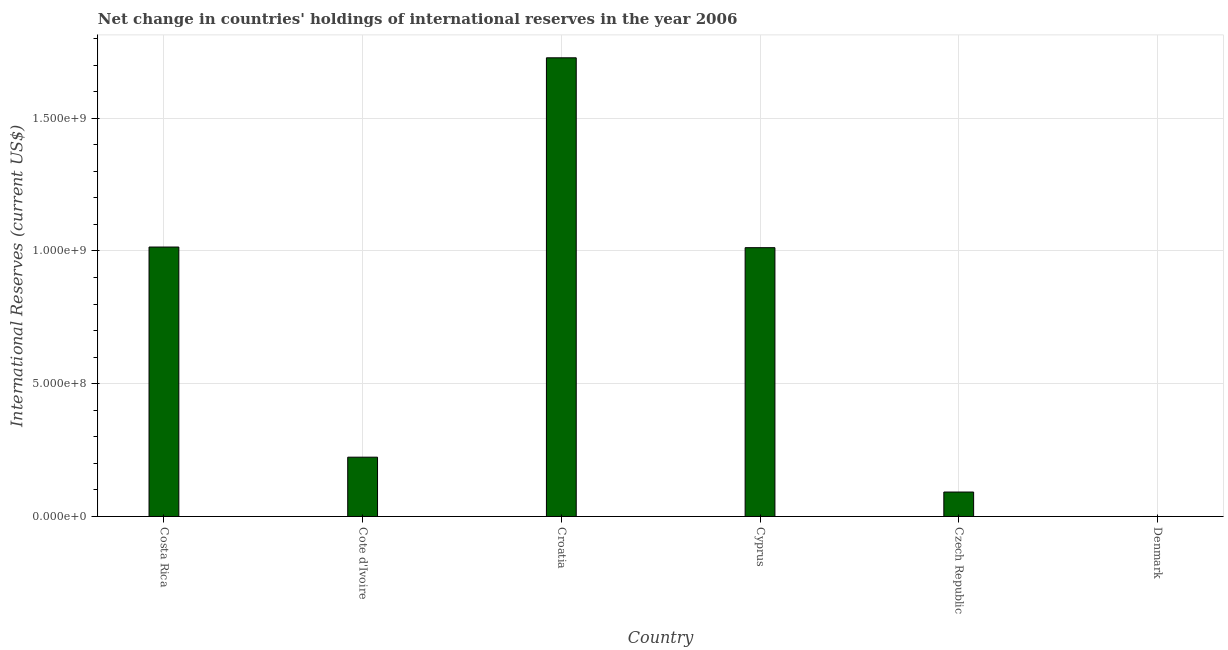Does the graph contain any zero values?
Provide a succinct answer. Yes. Does the graph contain grids?
Keep it short and to the point. Yes. What is the title of the graph?
Your response must be concise. Net change in countries' holdings of international reserves in the year 2006. What is the label or title of the Y-axis?
Your answer should be very brief. International Reserves (current US$). What is the reserves and related items in Cote d'Ivoire?
Make the answer very short. 2.23e+08. Across all countries, what is the maximum reserves and related items?
Give a very brief answer. 1.73e+09. In which country was the reserves and related items maximum?
Ensure brevity in your answer.  Croatia. What is the sum of the reserves and related items?
Give a very brief answer. 4.07e+09. What is the difference between the reserves and related items in Costa Rica and Czech Republic?
Offer a very short reply. 9.23e+08. What is the average reserves and related items per country?
Offer a very short reply. 6.78e+08. What is the median reserves and related items?
Your answer should be very brief. 6.18e+08. What is the ratio of the reserves and related items in Croatia to that in Cyprus?
Offer a terse response. 1.71. Is the difference between the reserves and related items in Croatia and Czech Republic greater than the difference between any two countries?
Your response must be concise. No. What is the difference between the highest and the second highest reserves and related items?
Make the answer very short. 7.13e+08. Is the sum of the reserves and related items in Cote d'Ivoire and Croatia greater than the maximum reserves and related items across all countries?
Your response must be concise. Yes. What is the difference between the highest and the lowest reserves and related items?
Your answer should be very brief. 1.73e+09. In how many countries, is the reserves and related items greater than the average reserves and related items taken over all countries?
Your response must be concise. 3. Are all the bars in the graph horizontal?
Provide a succinct answer. No. How many countries are there in the graph?
Provide a succinct answer. 6. Are the values on the major ticks of Y-axis written in scientific E-notation?
Give a very brief answer. Yes. What is the International Reserves (current US$) of Costa Rica?
Give a very brief answer. 1.01e+09. What is the International Reserves (current US$) of Cote d'Ivoire?
Provide a short and direct response. 2.23e+08. What is the International Reserves (current US$) of Croatia?
Your answer should be compact. 1.73e+09. What is the International Reserves (current US$) of Cyprus?
Offer a very short reply. 1.01e+09. What is the International Reserves (current US$) of Czech Republic?
Provide a succinct answer. 9.21e+07. What is the International Reserves (current US$) in Denmark?
Provide a short and direct response. 0. What is the difference between the International Reserves (current US$) in Costa Rica and Cote d'Ivoire?
Your answer should be very brief. 7.91e+08. What is the difference between the International Reserves (current US$) in Costa Rica and Croatia?
Offer a terse response. -7.13e+08. What is the difference between the International Reserves (current US$) in Costa Rica and Cyprus?
Offer a terse response. 2.44e+06. What is the difference between the International Reserves (current US$) in Costa Rica and Czech Republic?
Offer a terse response. 9.23e+08. What is the difference between the International Reserves (current US$) in Cote d'Ivoire and Croatia?
Offer a very short reply. -1.50e+09. What is the difference between the International Reserves (current US$) in Cote d'Ivoire and Cyprus?
Make the answer very short. -7.89e+08. What is the difference between the International Reserves (current US$) in Cote d'Ivoire and Czech Republic?
Your answer should be very brief. 1.31e+08. What is the difference between the International Reserves (current US$) in Croatia and Cyprus?
Your answer should be compact. 7.15e+08. What is the difference between the International Reserves (current US$) in Croatia and Czech Republic?
Your response must be concise. 1.64e+09. What is the difference between the International Reserves (current US$) in Cyprus and Czech Republic?
Offer a terse response. 9.20e+08. What is the ratio of the International Reserves (current US$) in Costa Rica to that in Cote d'Ivoire?
Make the answer very short. 4.54. What is the ratio of the International Reserves (current US$) in Costa Rica to that in Croatia?
Keep it short and to the point. 0.59. What is the ratio of the International Reserves (current US$) in Costa Rica to that in Cyprus?
Offer a very short reply. 1. What is the ratio of the International Reserves (current US$) in Costa Rica to that in Czech Republic?
Offer a terse response. 11.02. What is the ratio of the International Reserves (current US$) in Cote d'Ivoire to that in Croatia?
Give a very brief answer. 0.13. What is the ratio of the International Reserves (current US$) in Cote d'Ivoire to that in Cyprus?
Provide a succinct answer. 0.22. What is the ratio of the International Reserves (current US$) in Cote d'Ivoire to that in Czech Republic?
Make the answer very short. 2.42. What is the ratio of the International Reserves (current US$) in Croatia to that in Cyprus?
Provide a succinct answer. 1.71. What is the ratio of the International Reserves (current US$) in Croatia to that in Czech Republic?
Give a very brief answer. 18.76. What is the ratio of the International Reserves (current US$) in Cyprus to that in Czech Republic?
Provide a short and direct response. 10.99. 